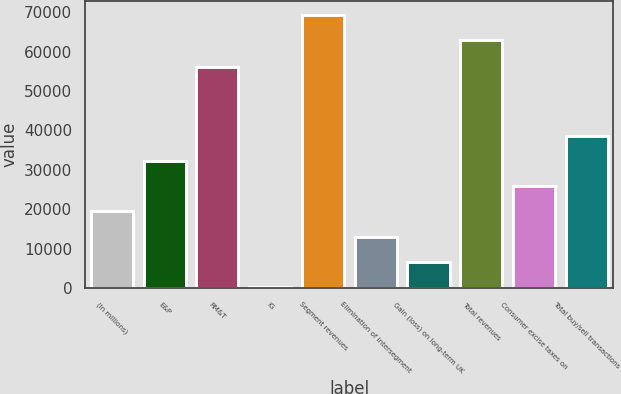Convert chart to OTSL. <chart><loc_0><loc_0><loc_500><loc_500><bar_chart><fcel>(In millions)<fcel>E&P<fcel>RM&T<fcel>IG<fcel>Segment revenues<fcel>Elimination of intersegment<fcel>Gain (loss) on long-term UK<fcel>Total revenues<fcel>Consumer excise taxes on<fcel>Total buy/sell transactions<nl><fcel>19439.6<fcel>32242<fcel>56003<fcel>236<fcel>69387.2<fcel>13038.4<fcel>6637.2<fcel>62986<fcel>25840.8<fcel>38643.2<nl></chart> 